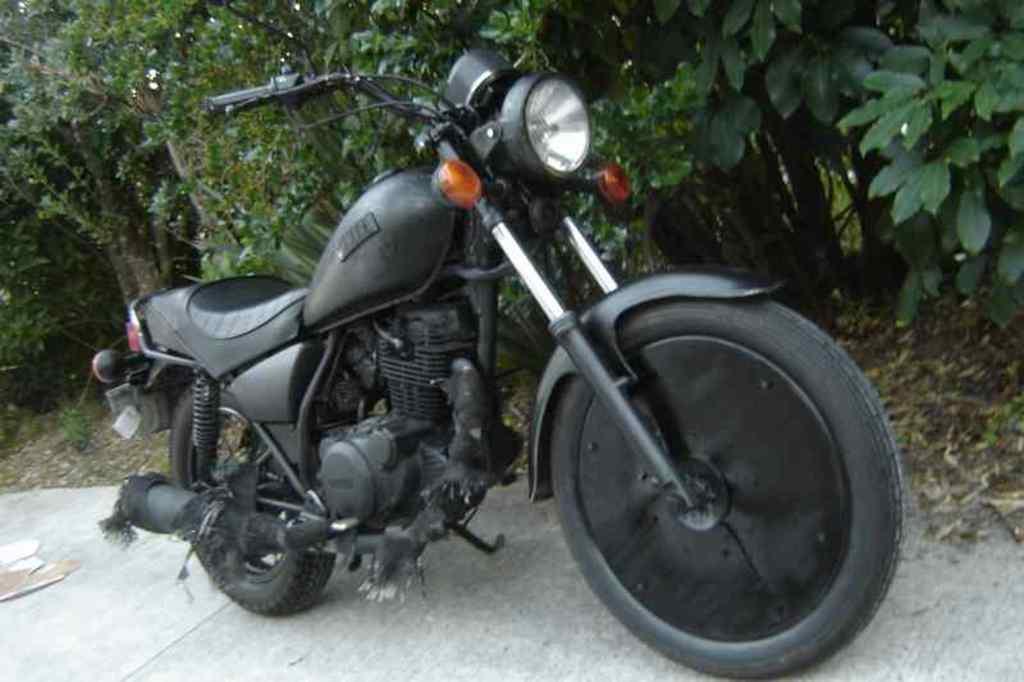Can you describe this image briefly? In the center of the image there is a bike. In the background of the image there are trees. At the bottom of the image there is road. 